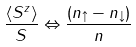<formula> <loc_0><loc_0><loc_500><loc_500>\frac { \langle S ^ { z } \rangle } { S } \Leftrightarrow \frac { ( n _ { \uparrow } - n _ { \downarrow } ) } { n }</formula> 